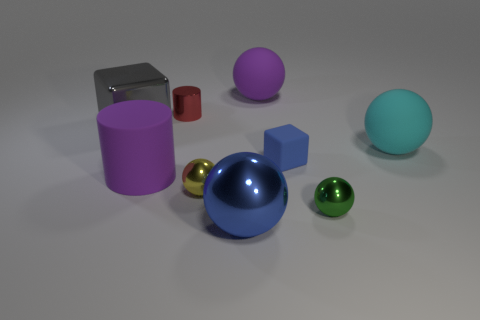Are there more big matte objects in front of the tiny red cylinder than metal spheres that are left of the purple cylinder? After analyzing the image, it appears that there are indeed more large matte objects in front of the tiny red cylinder than there are metal spheres to the left of the purple cylinder. Specifically, we can observe one big matte purple cylinder and a big blue cube positioned in front of the small red cylinder, while to the left of the big purple cylinder, there is only one metal sphere. Therefore, the quantity of larger matte objects in the specified area exceeds that of the metal spheres. 